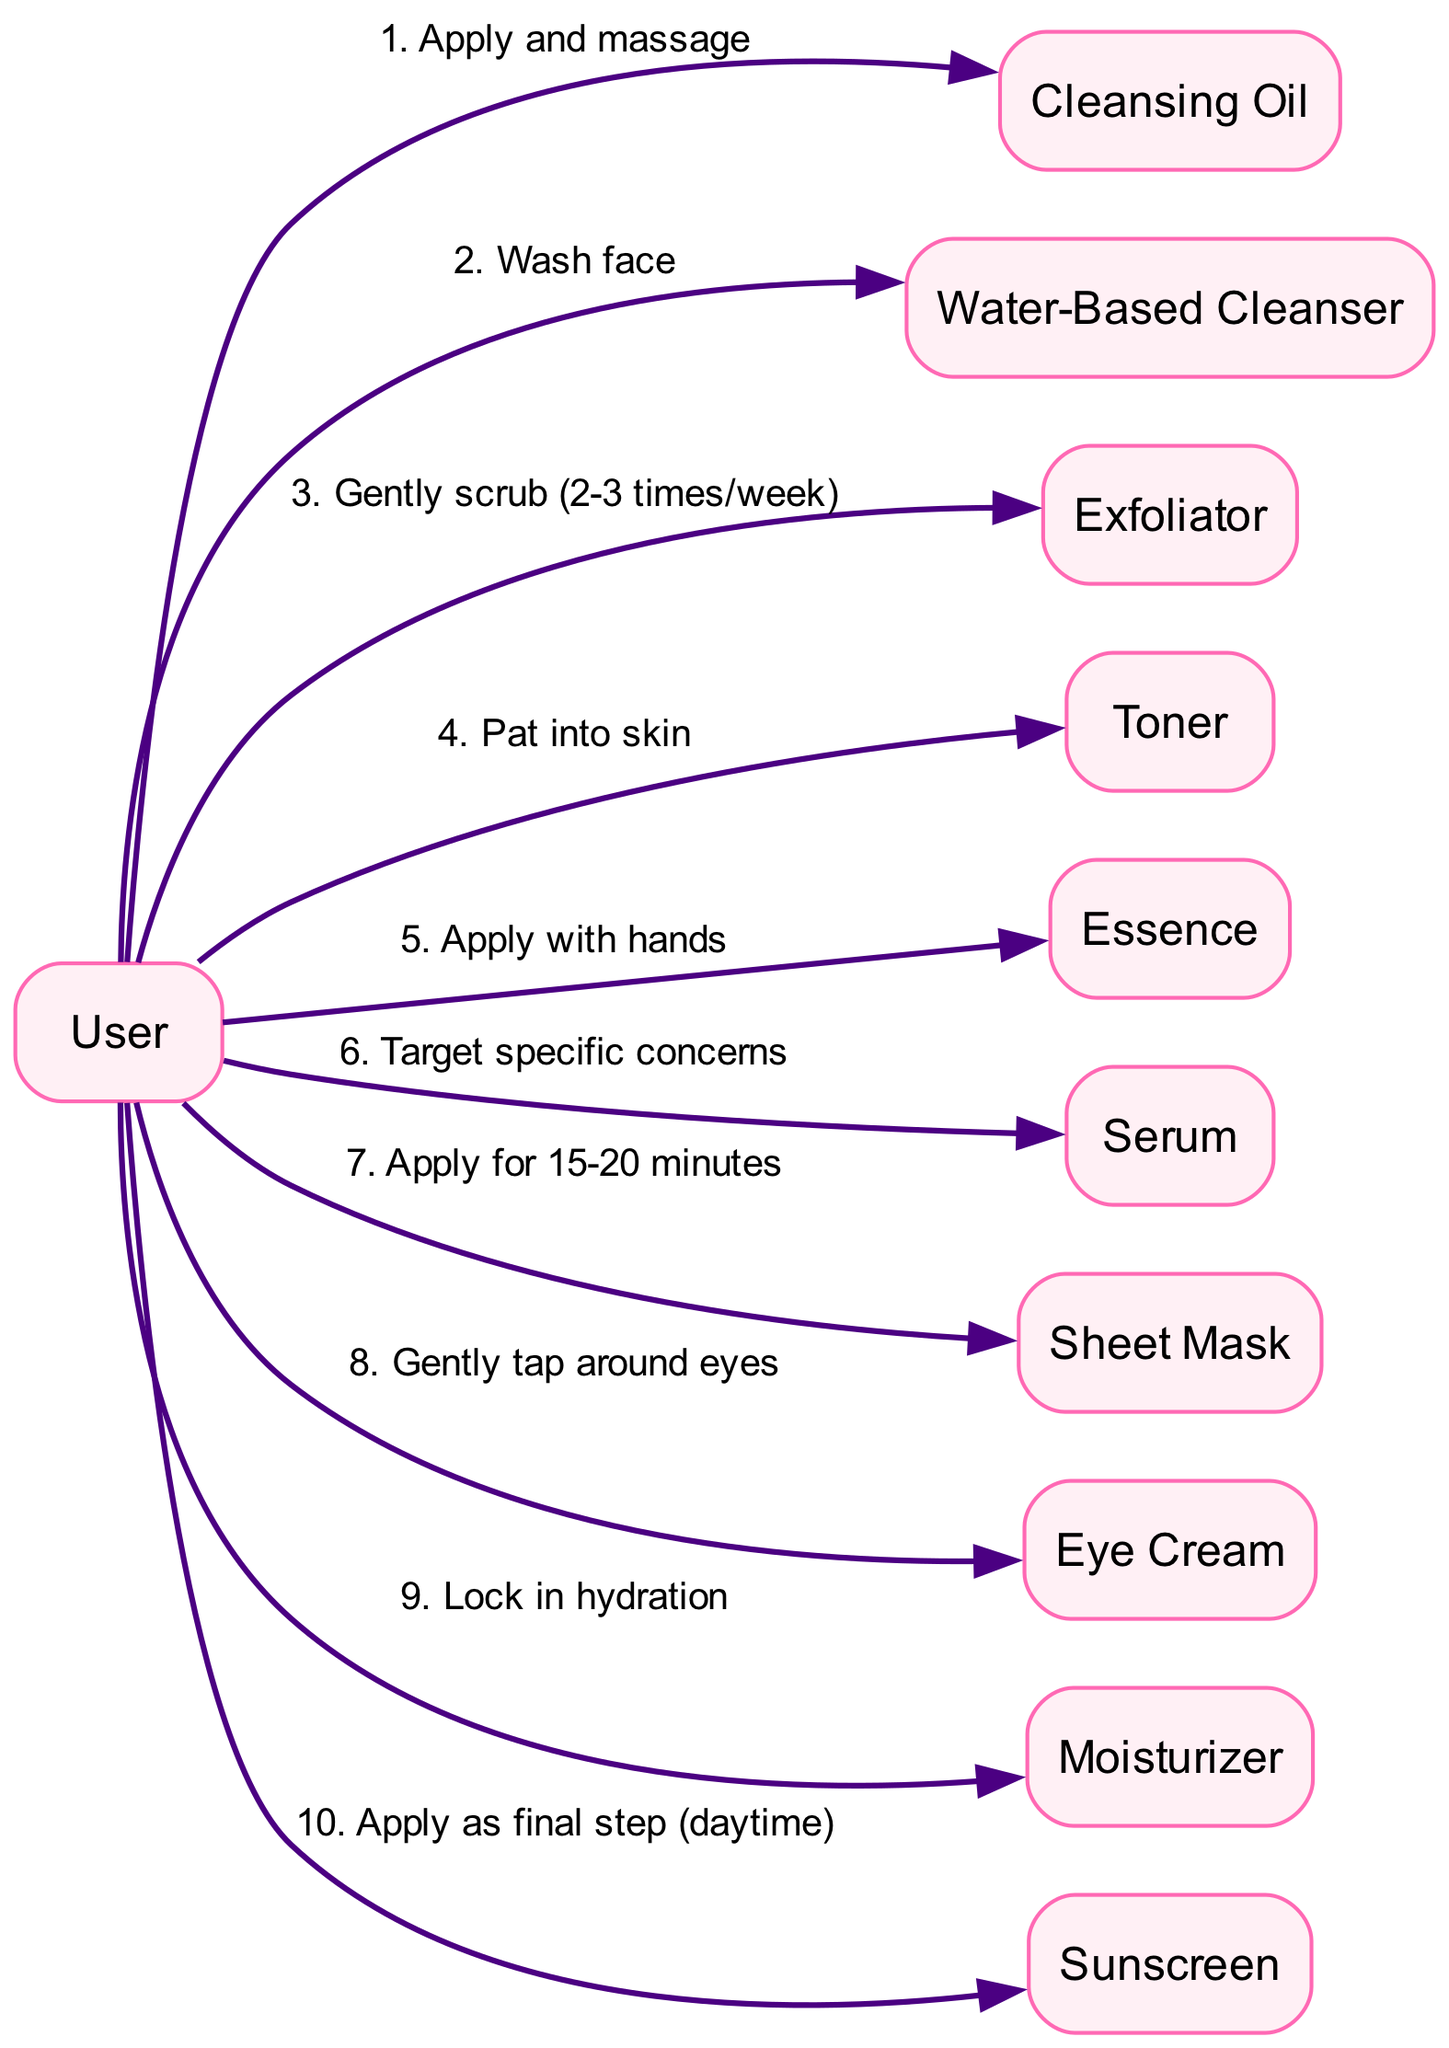What is the first step in the routine? The first step in the routine, as indicated in the diagram, is to "Apply and massage" with Cleansing Oil.
Answer: Apply and massage How many steps are there in the skincare routine? The diagram shows a total of 10 steps in the skincare routine, as represented by the number of edges connected from the User to different products.
Answer: 10 Which step involves applying a product for 15-20 minutes? The step involving applying a product for 15-20 minutes is the "Apply for 15-20 minutes" action with the Sheet Mask.
Answer: Apply for 15-20 minutes What is applied after the Essence? After the Essence, the next product applied is the Serum, as indicated in the sequence of actions from the User.
Answer: Serum What action is taken before moisturizing? Before moisturizing, the action taken is "Gently tap around eyes" with the Eye Cream.
Answer: Gently tap around eyes Which product is not involved in the daytime routine? The product not involved in the daytime skincare routine is the Sheet Mask, which is typically used in the evening.
Answer: Sheet Mask How does the flow of the routine end? The flow of the routine ends with "Apply as final step (daytime)" for Sunscreen, as shown in the last connection from the User.
Answer: Apply as final step (daytime) On which days is Exfoliator used? The Exfoliator is used "Gently scrub (2-3 times/week)," which indicates it is not a daily step.
Answer: 2-3 times/week What is the function of Toner in the routine? The function of Toner in the routine is to "Pat into skin," serving to prepare the skin for subsequent products.
Answer: Pat into skin 